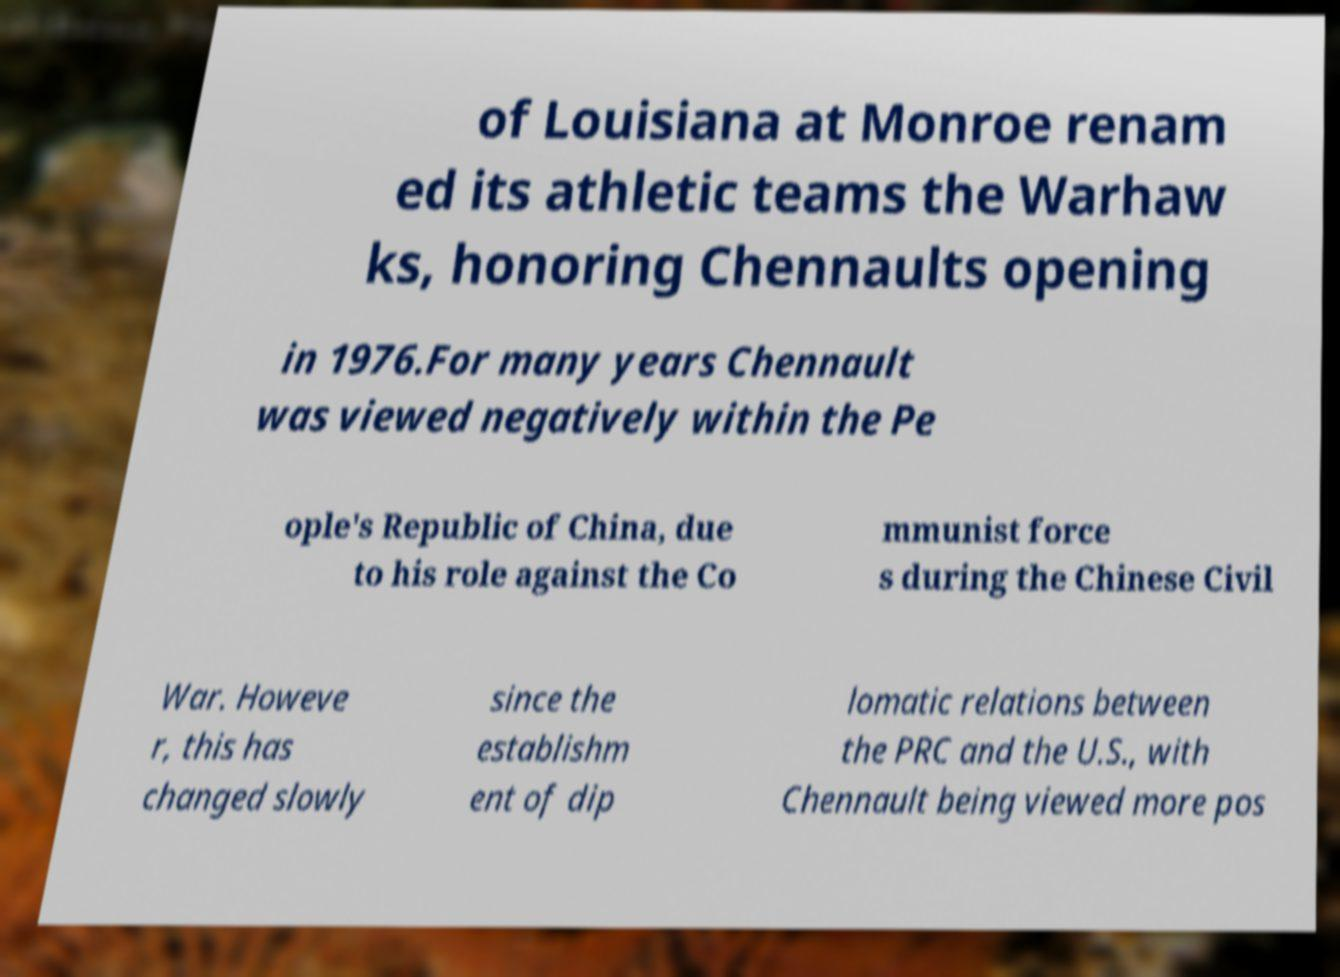Can you accurately transcribe the text from the provided image for me? of Louisiana at Monroe renam ed its athletic teams the Warhaw ks, honoring Chennaults opening in 1976.For many years Chennault was viewed negatively within the Pe ople's Republic of China, due to his role against the Co mmunist force s during the Chinese Civil War. Howeve r, this has changed slowly since the establishm ent of dip lomatic relations between the PRC and the U.S., with Chennault being viewed more pos 